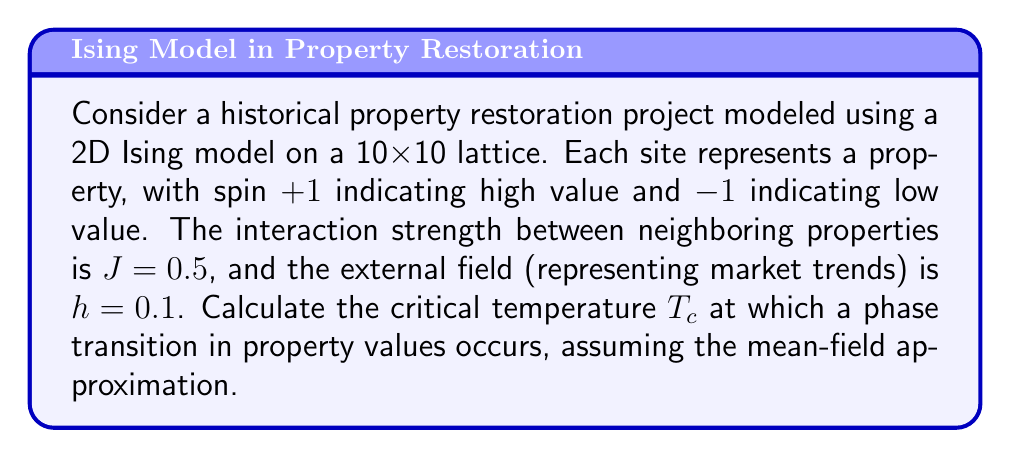Solve this math problem. To solve this problem, we'll use the mean-field approximation for the 2D Ising model:

1. In the mean-field theory, the critical temperature $T_c$ is given by:

   $$T_c = \frac{zJ}{k_B}$$

   where $z$ is the number of nearest neighbors, $J$ is the interaction strength, and $k_B$ is the Boltzmann constant.

2. For a 2D square lattice, $z = 4$ (each site has 4 nearest neighbors).

3. We're given $J = 0.5$.

4. Let's assume $k_B = 1$ for simplicity (we can consider the temperature in energy units).

5. Substituting these values into the equation:

   $$T_c = \frac{4 \cdot 0.5}{1} = 2$$

6. Note that the external field $h$ doesn't affect the critical temperature in the mean-field approximation, but it would influence the overall magnetization (or average property value in this context).

7. This critical temperature represents the point at which the system transitions from a disordered state (mixed high and low-value properties) to an ordered state (mostly high-value or mostly low-value properties).
Answer: $T_c = 2$ 